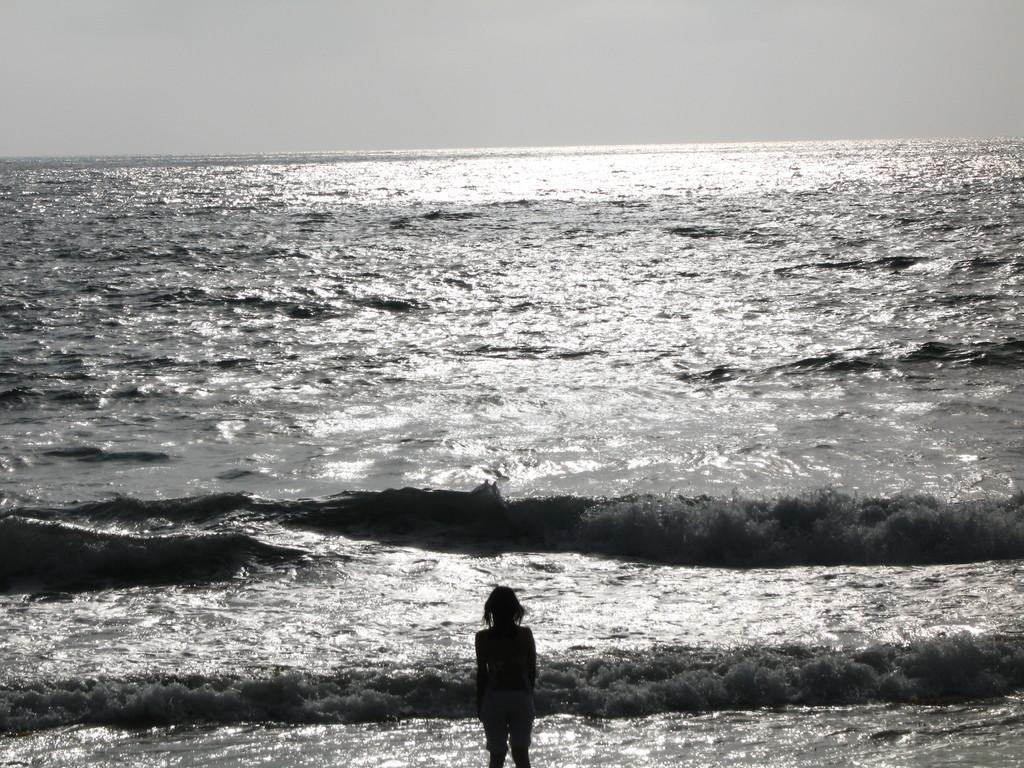What is visible in the image? There is water and a person visible in the image. Can you describe the person in the image? Unfortunately, the facts provided do not give any details about the person in the image. What is the primary element in the image? The primary element in the image is water. What type of toys can be seen floating in the water in the image? There are no toys visible in the image; it only shows water and a person. What kind of operation is being performed on the person in the image? There is no indication of any operation being performed on the person in the image. 